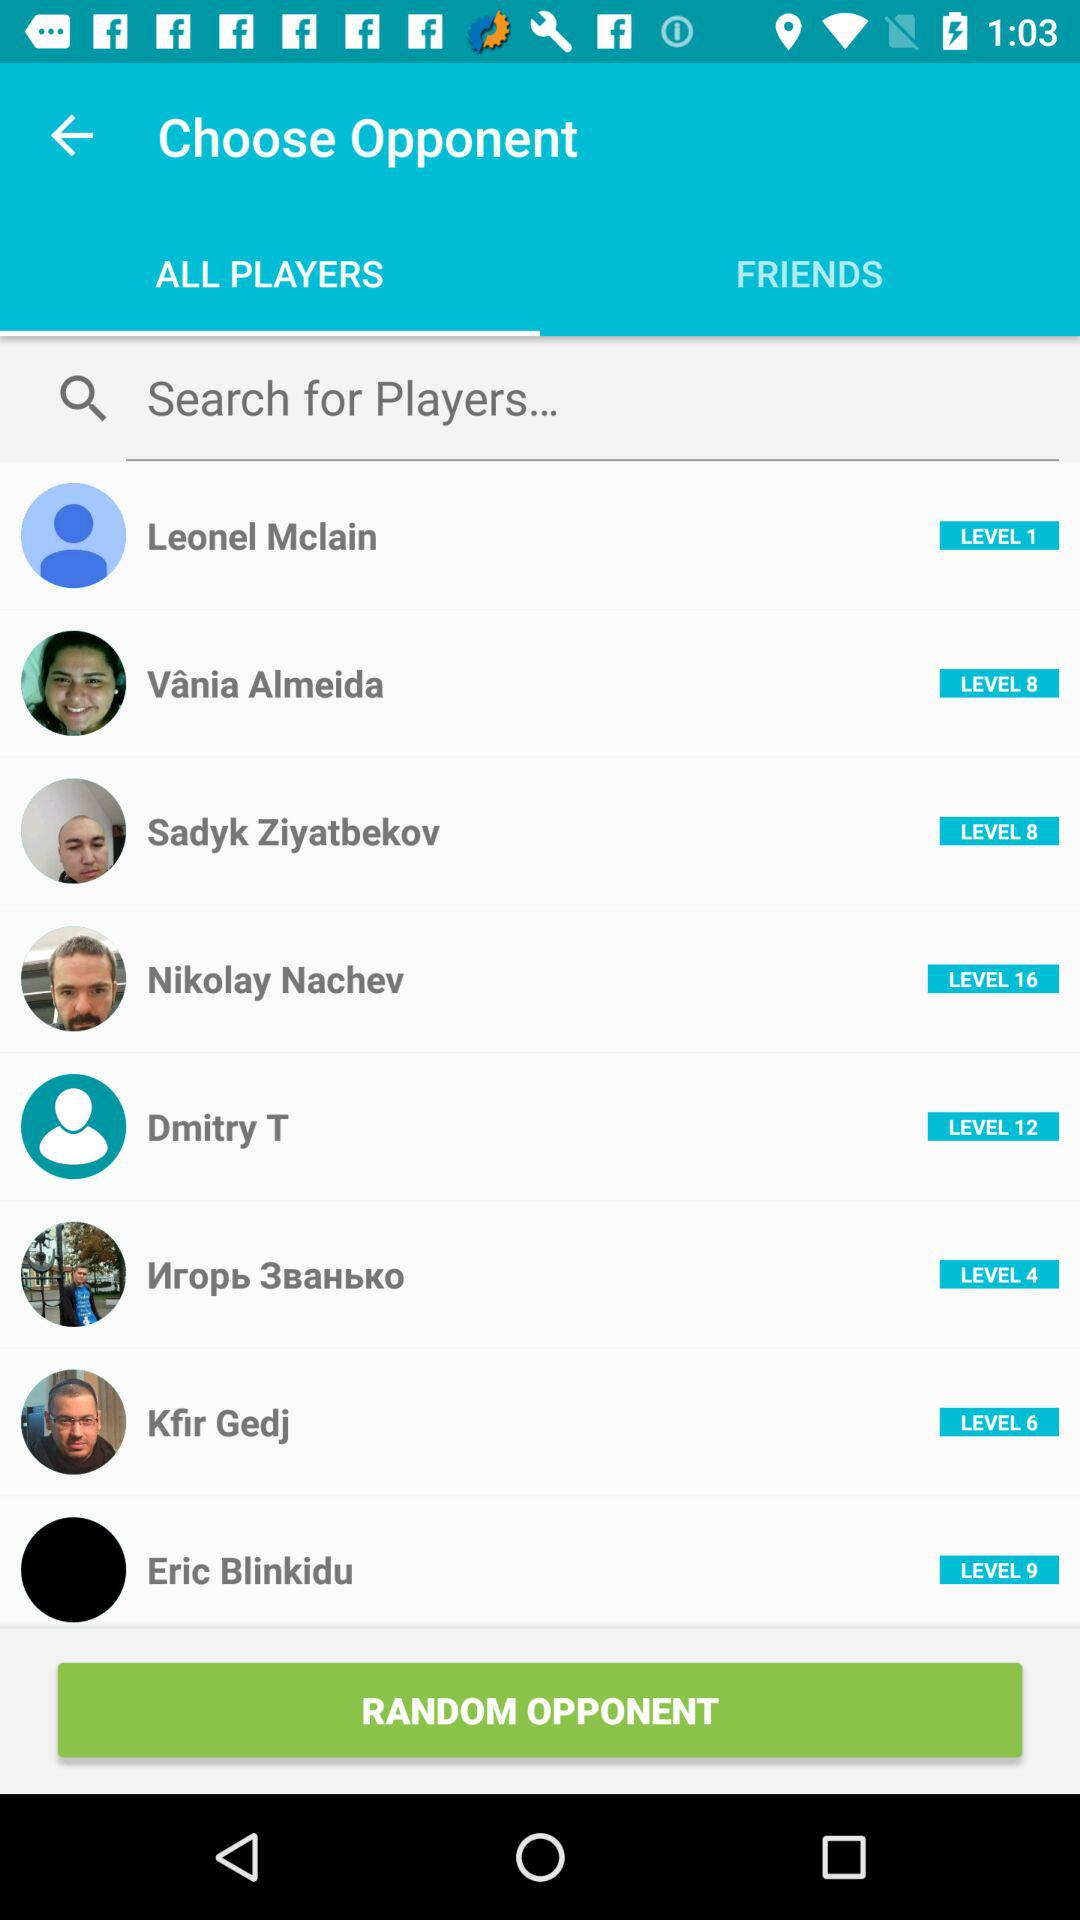What player is at level 16? The player is "Nikolay Nachev". 